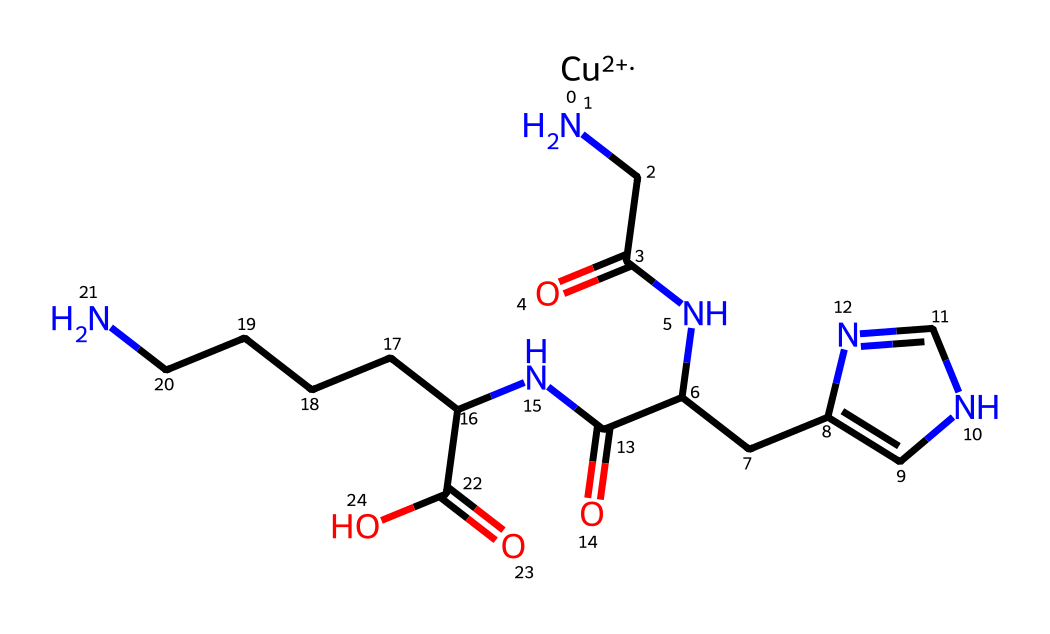What is the central metal ion in this structure? The central metal ion in this structure is represented by the notation [Cu+2]. This indicates that copper is at the core of the molecule, having a +2 oxidation state.
Answer: copper How many nitrogen atoms are present in the structure? By examining the SMILES representation, there are three distinct nitrogen atoms in the molecule, indicated by the 'N' symbols. Each 'N' corresponds to an individual nitrogen atom.
Answer: three What is the oxidation state of copper in this chemical? The oxidation state of copper is indicated by the notation +2 found within the brackets [Cu+2]. This shows that copper has lost two electrons.
Answer: +2 What type of molecule does this chemical represent? The presence of copper along with multiple peptide bonds and functional groups indicates that it is a copper peptide, a type of molecule known for potential biological activity, particularly in muscle recovery.
Answer: copper peptide Which functional group appears at the end of this structure? The structure contains a carboxylic acid functional group at the end, indicated by the “C(=O)O” notation, which includes a carbon double bonded to oxygen and single bonded to a hydroxyl group (−OH).
Answer: carboxylic acid How many carbon atoms are present in this structure? Counting the carbon atoms based on the structure presented in the SMILES representation, there are a total of 12 carbon atoms identified in the entire molecule.
Answer: twelve 